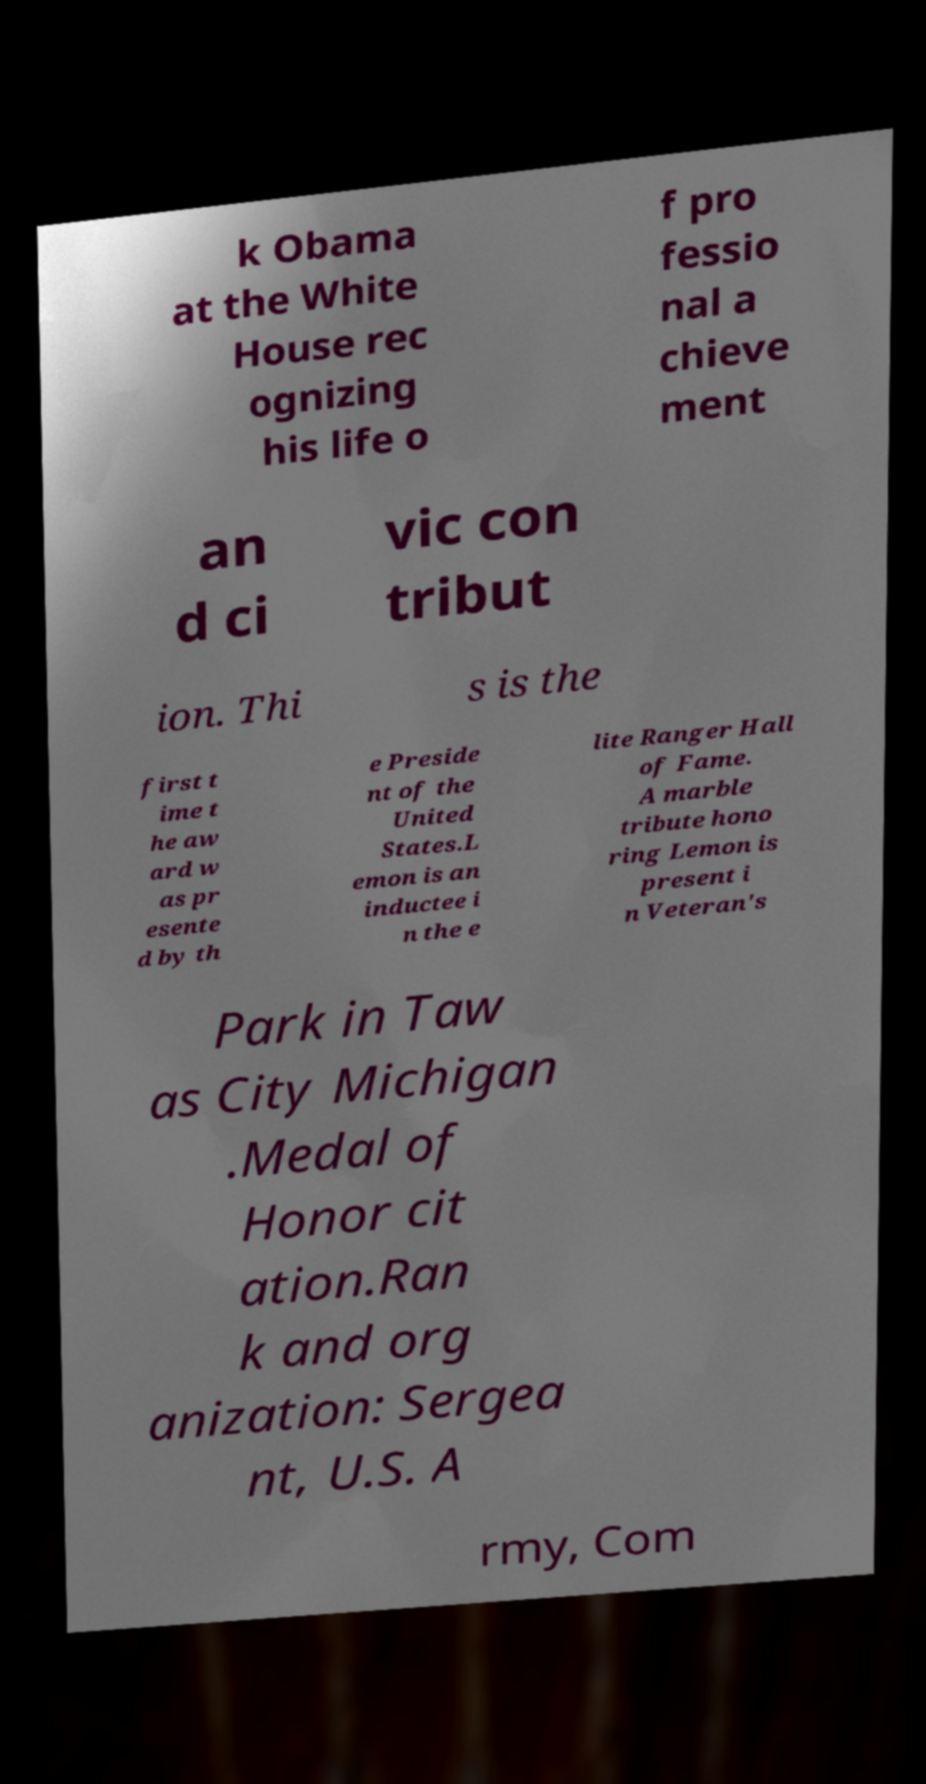Please read and relay the text visible in this image. What does it say? k Obama at the White House rec ognizing his life o f pro fessio nal a chieve ment an d ci vic con tribut ion. Thi s is the first t ime t he aw ard w as pr esente d by th e Preside nt of the United States.L emon is an inductee i n the e lite Ranger Hall of Fame. A marble tribute hono ring Lemon is present i n Veteran's Park in Taw as City Michigan .Medal of Honor cit ation.Ran k and org anization: Sergea nt, U.S. A rmy, Com 